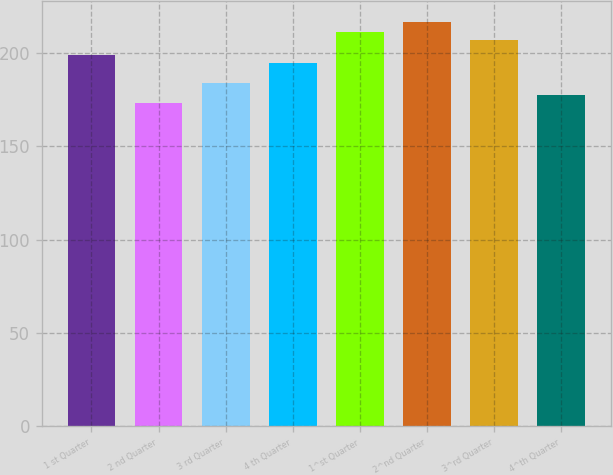Convert chart. <chart><loc_0><loc_0><loc_500><loc_500><bar_chart><fcel>1 st Quarter<fcel>2 nd Quarter<fcel>3 rd Quarter<fcel>4 th Quarter<fcel>1^st Quarter<fcel>2^nd Quarter<fcel>3^rd Quarter<fcel>4^th Quarter<nl><fcel>198.83<fcel>173.02<fcel>183.72<fcel>194.44<fcel>211.4<fcel>216.9<fcel>207.01<fcel>177.67<nl></chart> 